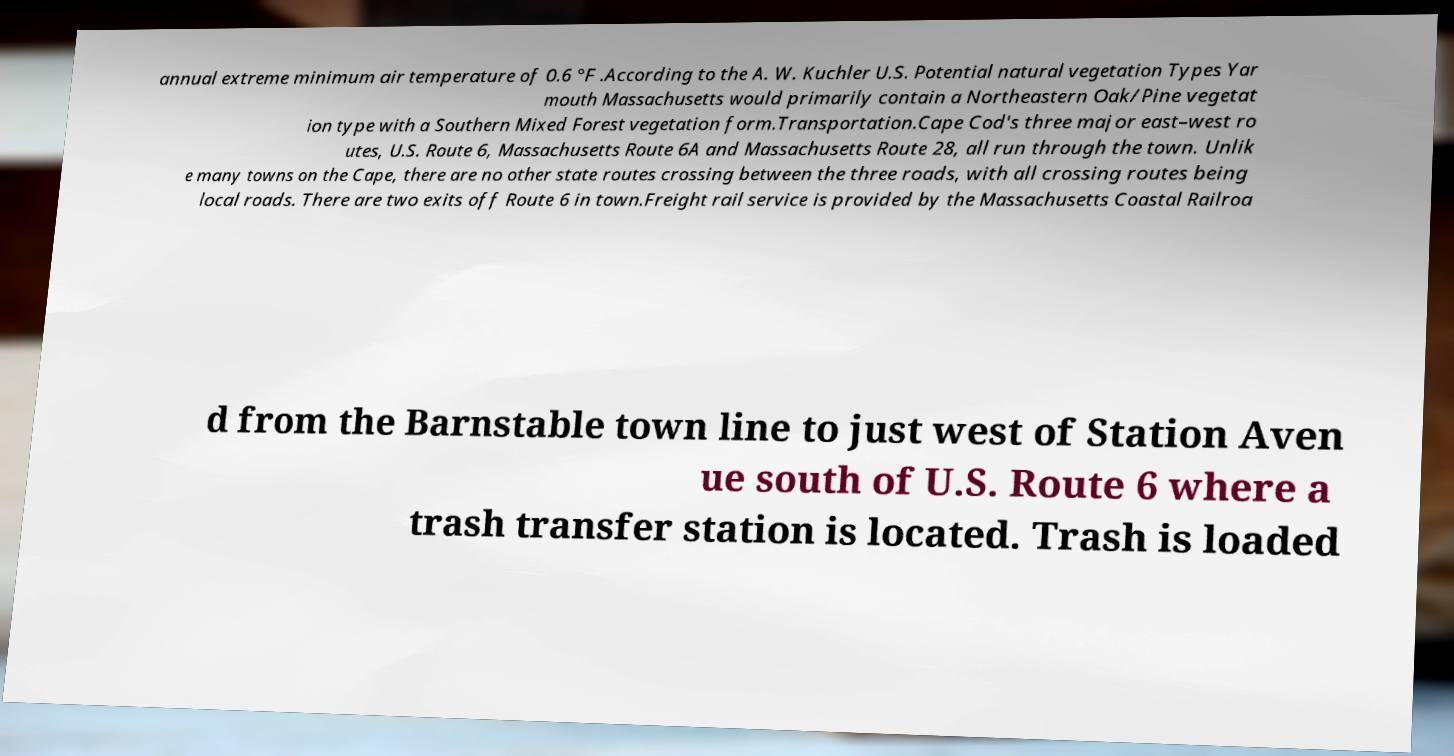Can you read and provide the text displayed in the image?This photo seems to have some interesting text. Can you extract and type it out for me? annual extreme minimum air temperature of 0.6 °F .According to the A. W. Kuchler U.S. Potential natural vegetation Types Yar mouth Massachusetts would primarily contain a Northeastern Oak/Pine vegetat ion type with a Southern Mixed Forest vegetation form.Transportation.Cape Cod's three major east–west ro utes, U.S. Route 6, Massachusetts Route 6A and Massachusetts Route 28, all run through the town. Unlik e many towns on the Cape, there are no other state routes crossing between the three roads, with all crossing routes being local roads. There are two exits off Route 6 in town.Freight rail service is provided by the Massachusetts Coastal Railroa d from the Barnstable town line to just west of Station Aven ue south of U.S. Route 6 where a trash transfer station is located. Trash is loaded 